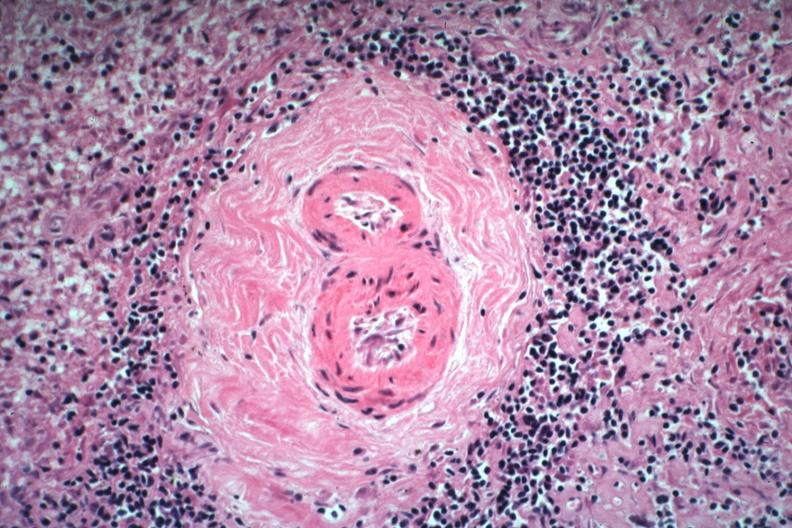s hematologic present?
Answer the question using a single word or phrase. Yes 